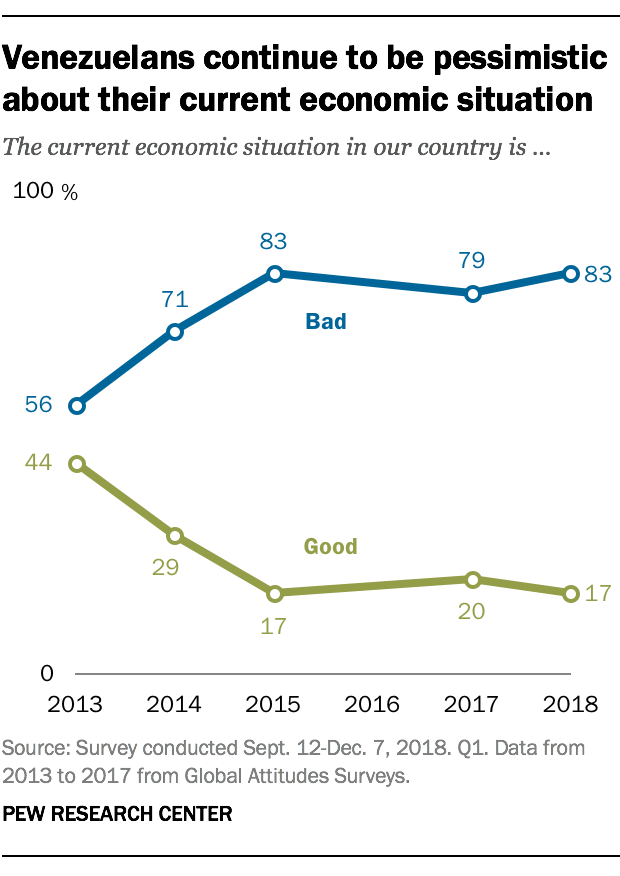Highlight a few significant elements in this photo. The year with the largest gap between two ratings was 2015. The peak of the good rating was reached in 2013. 